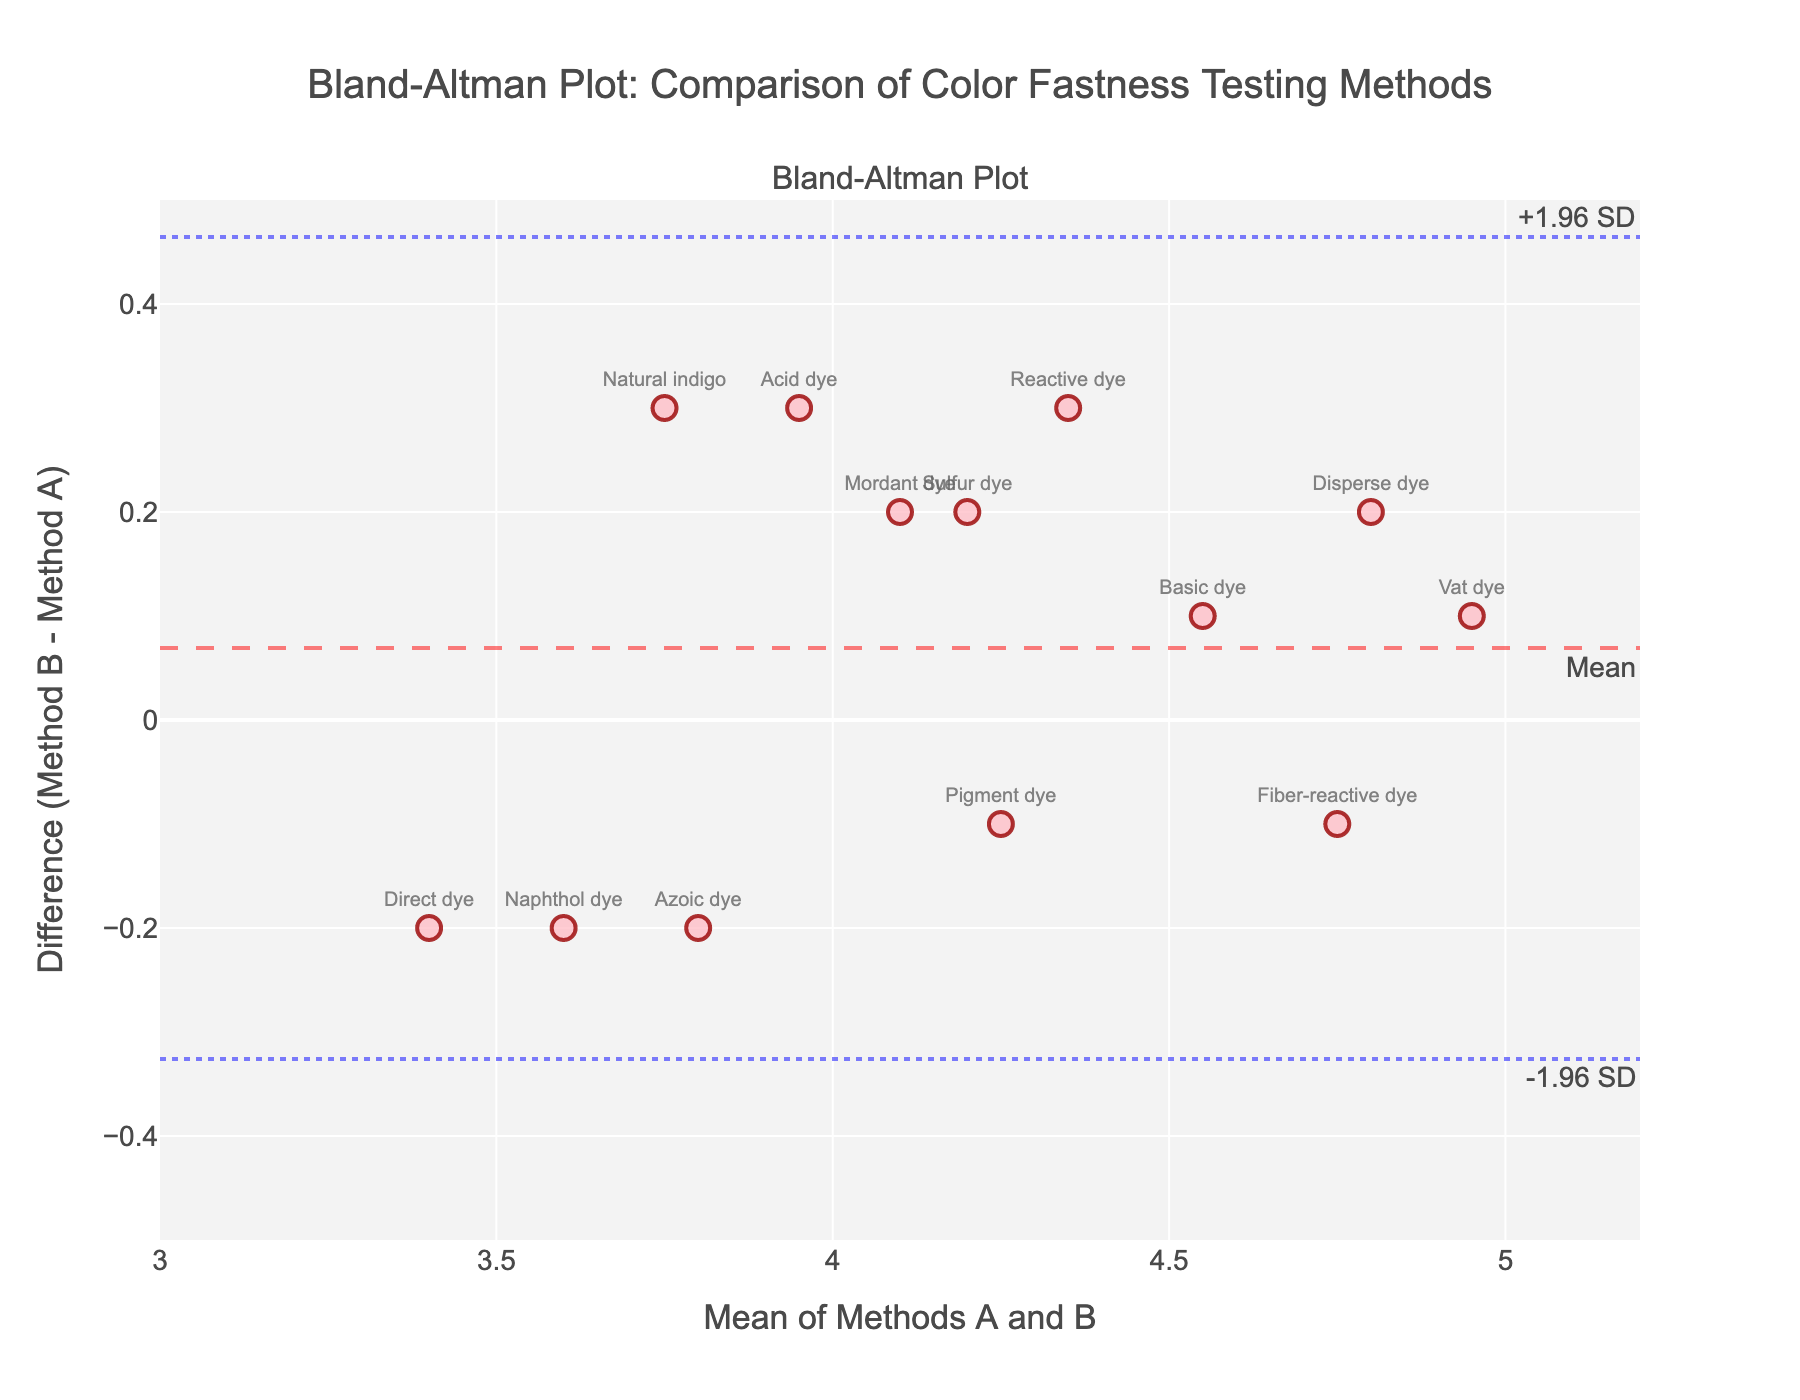What's the title of the plot? The title is usually written at the top of the figure in a larger font size. It helps the viewer understand the main subject of the plot.
Answer: Bland-Altman Plot: Comparison of Color Fastness Testing Methods What are the axes labeled in the plot? The labels are typically present along the x-axis and y-axis to describe what those axes represent in the plot.
Answer: The x-axis is labeled "Mean of Methods A and B," and the y-axis is labeled "Difference (Method B - Method A)." How many dye types are represented in the plot? Each dye type is represented as an individual data point on the scatter plot, and the names are displayed next to some points. By counting these points, we can determine the number of dye types.
Answer: There are 13 dye types What is the mean difference line value? The mean difference line is typically labeled and aligned horizontally across the plot. Its annotation explains what it represents.
Answer: The mean difference line value is around 0 What are the upper and lower limits of agreement? The limits of agreement are often marked with dashed or dotted lines. They represent the mean difference plus or minus 1.96 times the standard deviation.
Answer: The upper limit is around +0.2, and the lower limit is around -0.2 Which dye type has the highest mean color fastness rating? To find this, look for the data point with the highest x-axis value, as the x-axis represents the Mean of Methods A and B.
Answer: Vat dye Which dye type shows the largest difference between Method A and Method B? To identify this, look for the data point that is farthest from the mean difference line in terms of vertical distance.
Answer: Disperse dye How do the Disperse dye and Natural indigo compare in their differences between Method A and Method B? By comparing the y-axis positions of these two dye types, we can see how their differences compare relative to each other.
Answer: Disperse dye has a positive difference, while Natural indigo has a small positive difference What does a data point below the mean difference line indicate in terms of Method A and Method B? A point below this line shows that the value from Method B is less than the value from Method A.
Answer: Method B is lower than Method A Are there any dye types that show a negative difference in color fastness rating? Observing the y-axis values for points below zero will indicate which dye types have a negative difference.
Answer: Yes, Azoic dye and Naphthol dye show a negative difference 